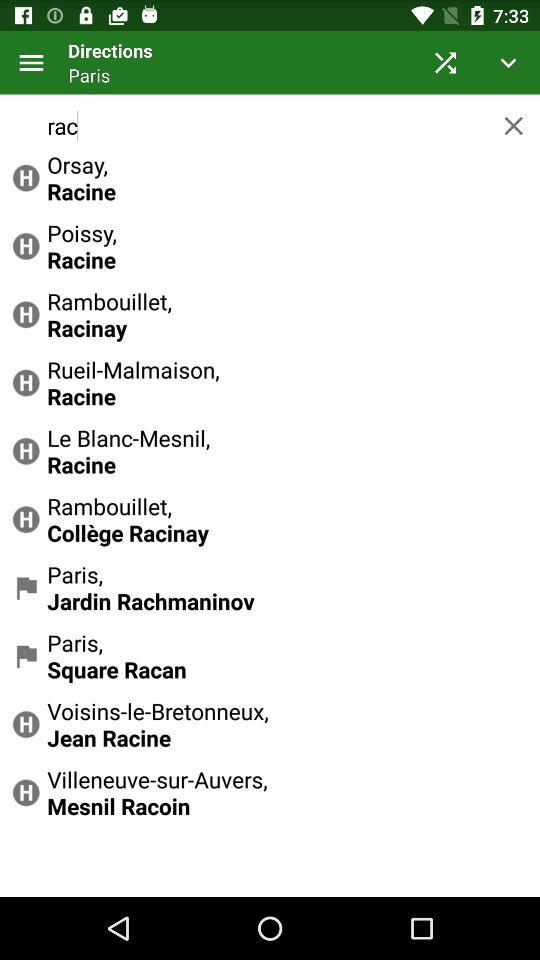What is the mentioned location? The mentioned location is Paris. 